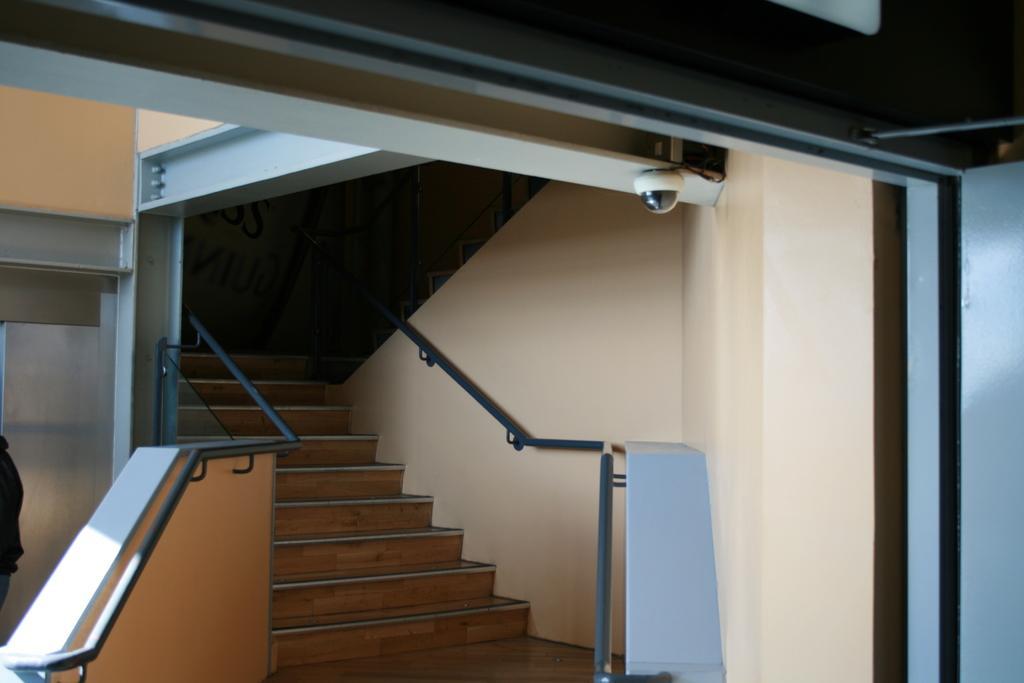Describe this image in one or two sentences. In this picture we can see steps, few metal rods and a security camera, on the left side of the image we can see a person. 